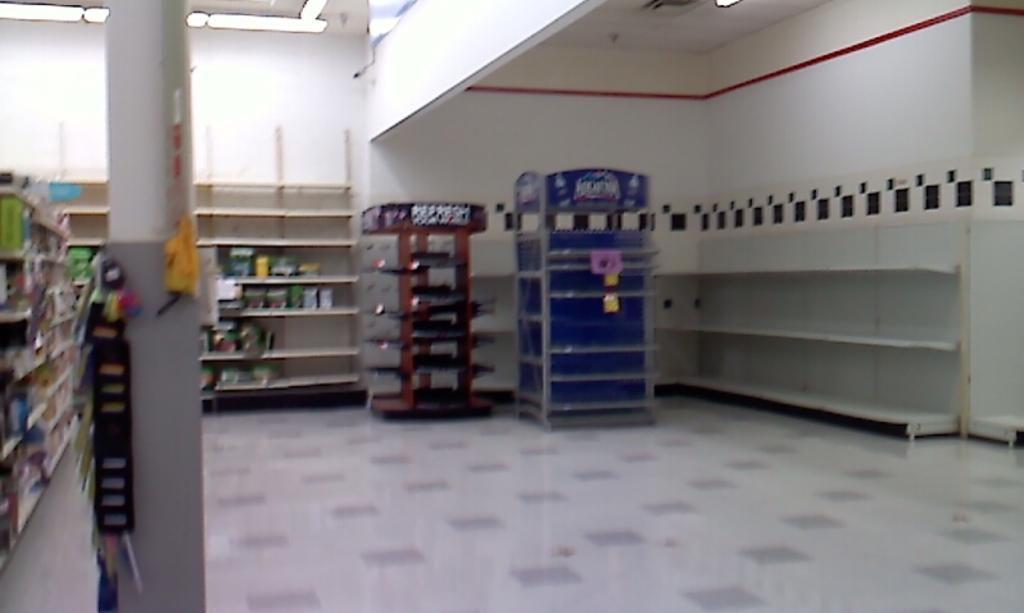<image>
Present a compact description of the photo's key features. Shelves in a store are nearly bare; there is no water on the Aquifina display. 